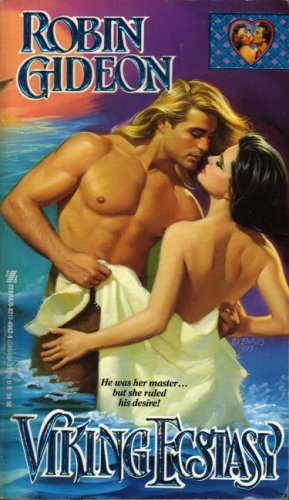What is the title of this book? The book pictured is titled 'Viking Ecstasy', published under Zebra Books, showcasing a passionate romance theme. 